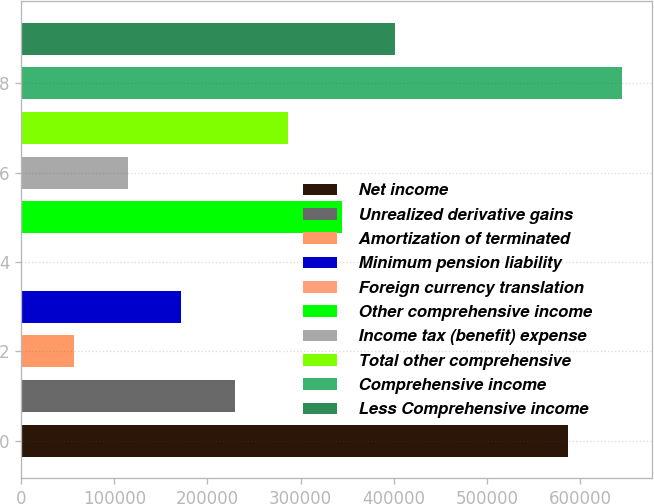<chart> <loc_0><loc_0><loc_500><loc_500><bar_chart><fcel>Net income<fcel>Unrealized derivative gains<fcel>Amortization of terminated<fcel>Minimum pension liability<fcel>Foreign currency translation<fcel>Other comprehensive income<fcel>Income tax (benefit) expense<fcel>Total other comprehensive<fcel>Comprehensive income<fcel>Less Comprehensive income<nl><fcel>587413<fcel>229349<fcel>57339.3<fcel>172012<fcel>2.9<fcel>344021<fcel>114676<fcel>286685<fcel>644750<fcel>401358<nl></chart> 